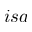<formula> <loc_0><loc_0><loc_500><loc_500>i s a</formula> 